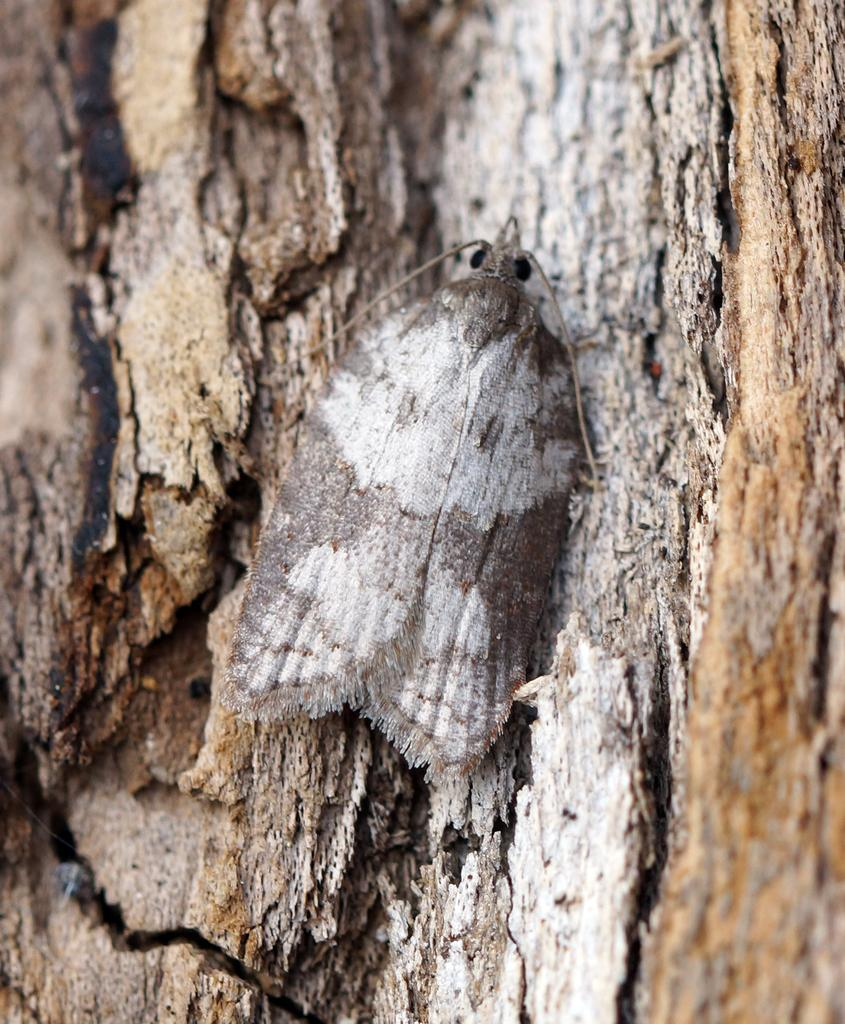What is the main subject of the image? The main subject of the image is a tree stem. Are there any other living organisms present in the image? Yes, there is an insect in the image. What type of honey is the insect collecting from the tree stem in the image? There is no honey present in the image, and the insect is not collecting anything from the tree stem. 